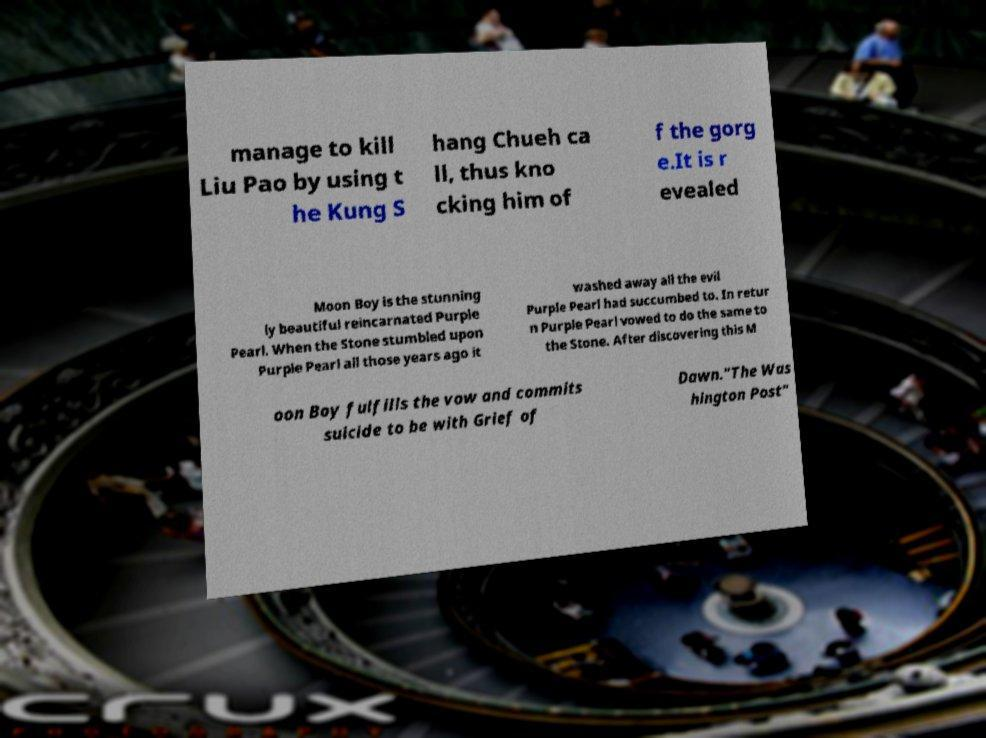Please identify and transcribe the text found in this image. manage to kill Liu Pao by using t he Kung S hang Chueh ca ll, thus kno cking him of f the gorg e.It is r evealed Moon Boy is the stunning ly beautiful reincarnated Purple Pearl. When the Stone stumbled upon Purple Pearl all those years ago it washed away all the evil Purple Pearl had succumbed to. In retur n Purple Pearl vowed to do the same to the Stone. After discovering this M oon Boy fulfills the vow and commits suicide to be with Grief of Dawn."The Was hington Post" 